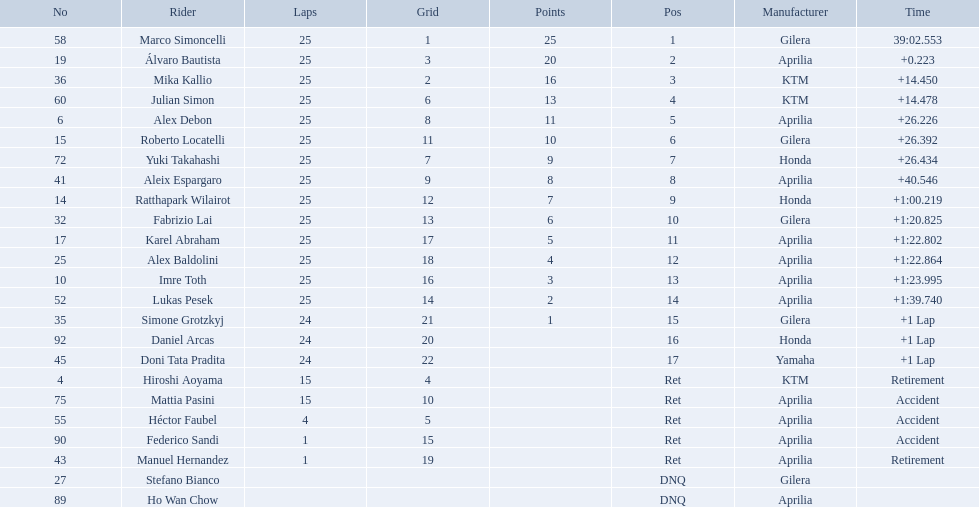Who were all of the riders? Marco Simoncelli, Álvaro Bautista, Mika Kallio, Julian Simon, Alex Debon, Roberto Locatelli, Yuki Takahashi, Aleix Espargaro, Ratthapark Wilairot, Fabrizio Lai, Karel Abraham, Alex Baldolini, Imre Toth, Lukas Pesek, Simone Grotzkyj, Daniel Arcas, Doni Tata Pradita, Hiroshi Aoyama, Mattia Pasini, Héctor Faubel, Federico Sandi, Manuel Hernandez, Stefano Bianco, Ho Wan Chow. How many laps did they complete? 25, 25, 25, 25, 25, 25, 25, 25, 25, 25, 25, 25, 25, 25, 24, 24, 24, 15, 15, 4, 1, 1, , . Between marco simoncelli and hiroshi aoyama, who had more laps? Marco Simoncelli. 